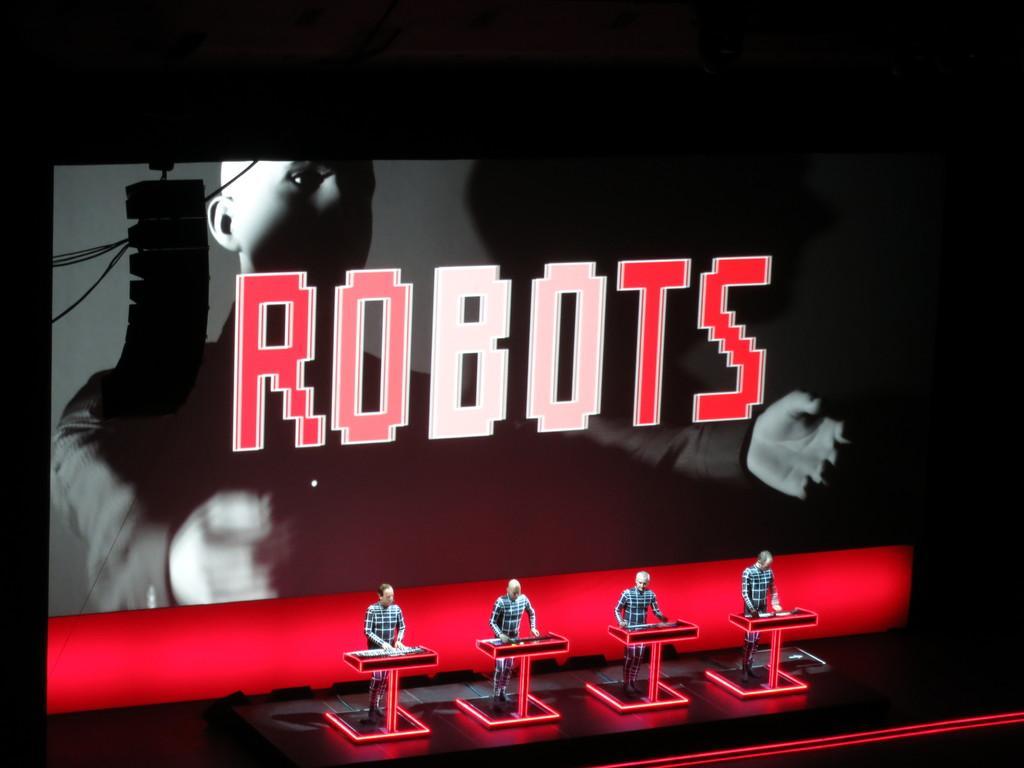Describe this image in one or two sentences. At the bottom of the picture, we see four men are standing. In front of them, we see the podiums which are in red and black color. They might be standing on the stage. Behind them, we see a projector screen which is displaying the text and the robot. Beside that, we see a black color object. In the background, it is black in color. 